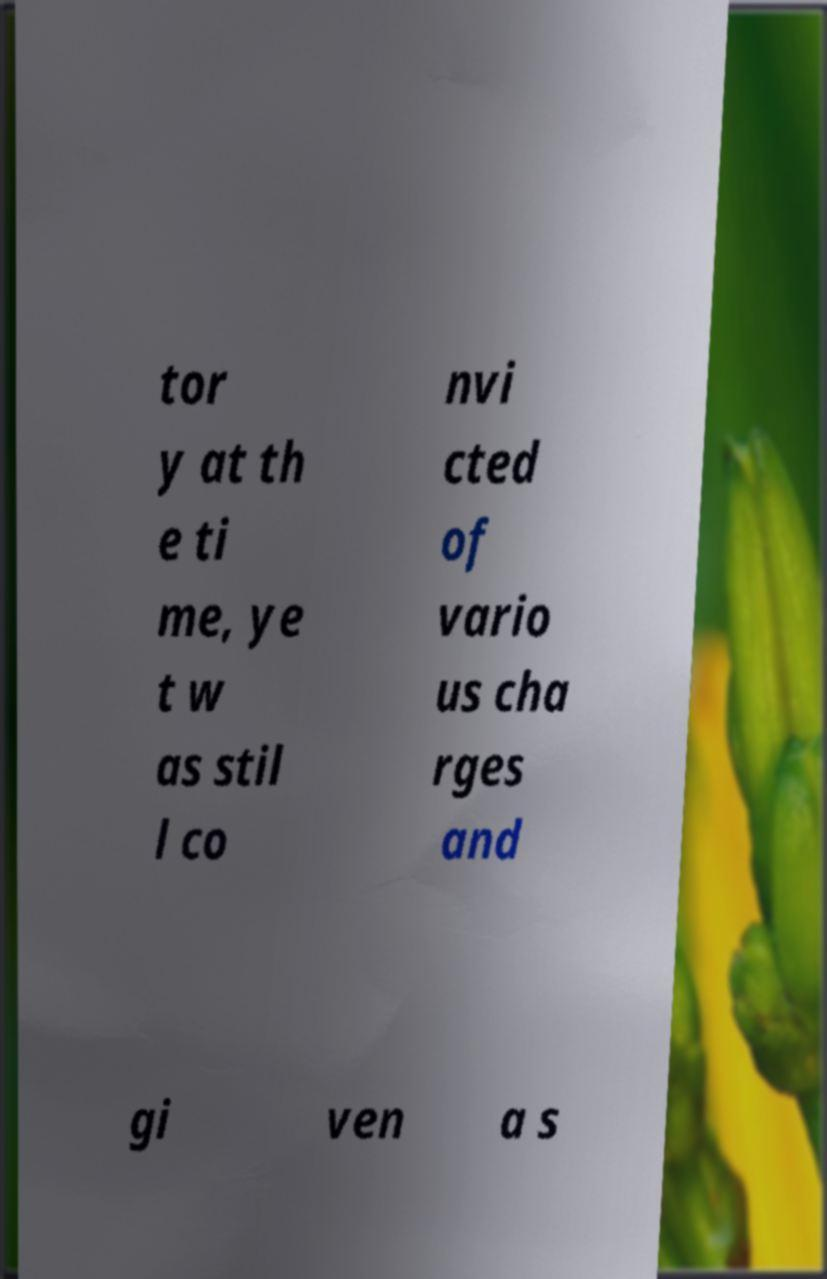For documentation purposes, I need the text within this image transcribed. Could you provide that? tor y at th e ti me, ye t w as stil l co nvi cted of vario us cha rges and gi ven a s 